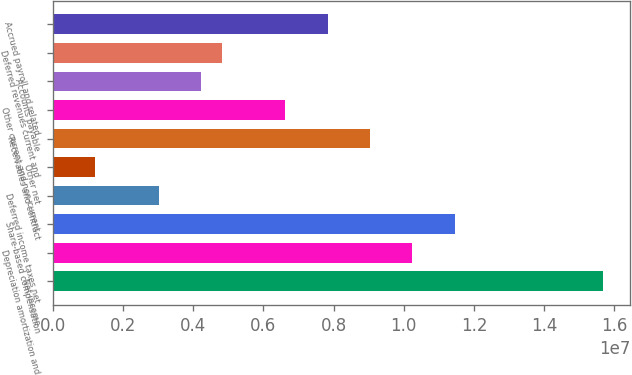<chart> <loc_0><loc_0><loc_500><loc_500><bar_chart><fcel>Net income<fcel>Depreciation amortization and<fcel>Share-based compensation<fcel>Deferred income taxes net<fcel>Other net<fcel>Receivables and contract<fcel>Other current and non-current<fcel>Accounts payable<fcel>Deferred revenues current and<fcel>Accrued payroll and related<nl><fcel>1.56627e+07<fcel>1.02424e+07<fcel>1.14469e+07<fcel>3.01544e+06<fcel>1.20869e+06<fcel>9.03794e+06<fcel>6.62894e+06<fcel>4.21994e+06<fcel>4.82219e+06<fcel>7.83344e+06<nl></chart> 